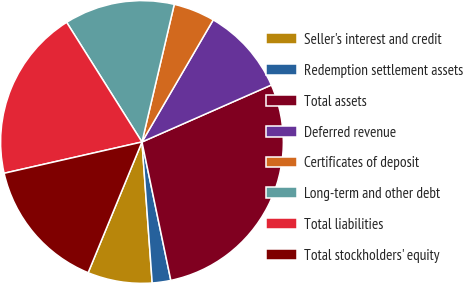Convert chart to OTSL. <chart><loc_0><loc_0><loc_500><loc_500><pie_chart><fcel>Seller's interest and credit<fcel>Redemption settlement assets<fcel>Total assets<fcel>Deferred revenue<fcel>Certificates of deposit<fcel>Long-term and other debt<fcel>Total liabilities<fcel>Total stockholders' equity<nl><fcel>7.37%<fcel>2.12%<fcel>28.33%<fcel>9.99%<fcel>4.74%<fcel>12.61%<fcel>19.61%<fcel>15.23%<nl></chart> 